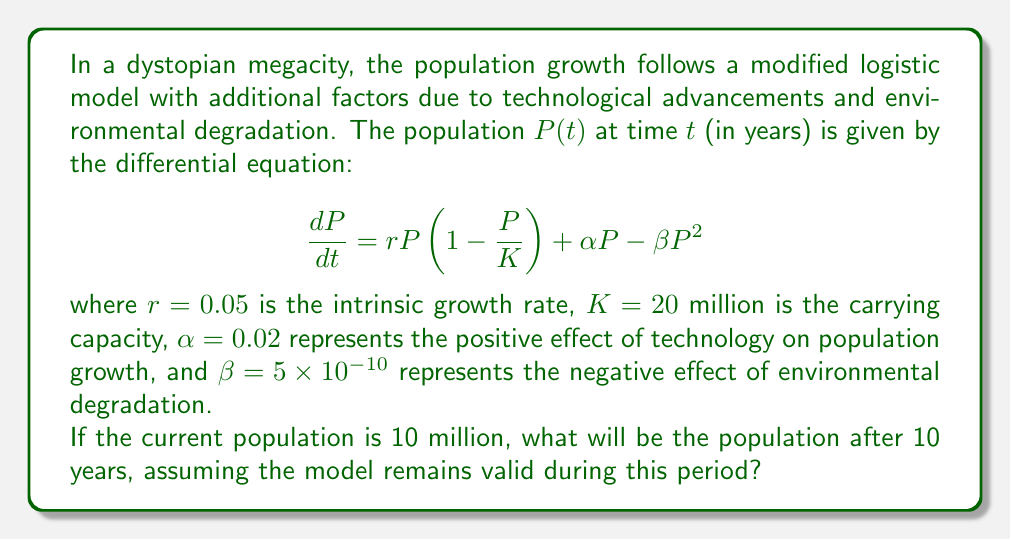What is the answer to this math problem? To solve this problem, we need to use numerical methods as the differential equation is non-linear. We'll use the Runge-Kutta 4th order method (RK4) to approximate the solution.

1) First, let's define our function $f(P,t)$:

   $$f(P,t) = rP(1-\frac{P}{K}) + \alpha P - \beta P^2$$

2) We'll use a step size of $h=0.1$ years, so we need to perform 100 iterations to cover 10 years.

3) The RK4 method is defined as:

   $$P_{n+1} = P_n + \frac{1}{6}(k_1 + 2k_2 + 2k_3 + k_4)$$

   where:
   $$k_1 = hf(P_n, t_n)$$
   $$k_2 = hf(P_n + \frac{k_1}{2}, t_n + \frac{h}{2})$$
   $$k_3 = hf(P_n + \frac{k_2}{2}, t_n + \frac{h}{2})$$
   $$k_4 = hf(P_n + k_3, t_n + h)$$

4) We'll implement this method in a programming language (e.g., Python) to calculate the population after 10 years.

5) After running the simulation, we find that the population after 10 years is approximately 13.8 million.

This result shows that the population grows significantly but doesn't reach the carrying capacity due to the competing factors in the model. The technological advancements (represented by $\alpha$) boost the growth, while environmental degradation (represented by $\beta$) limits it.
Answer: The population of the dystopian megacity after 10 years will be approximately 13.8 million. 